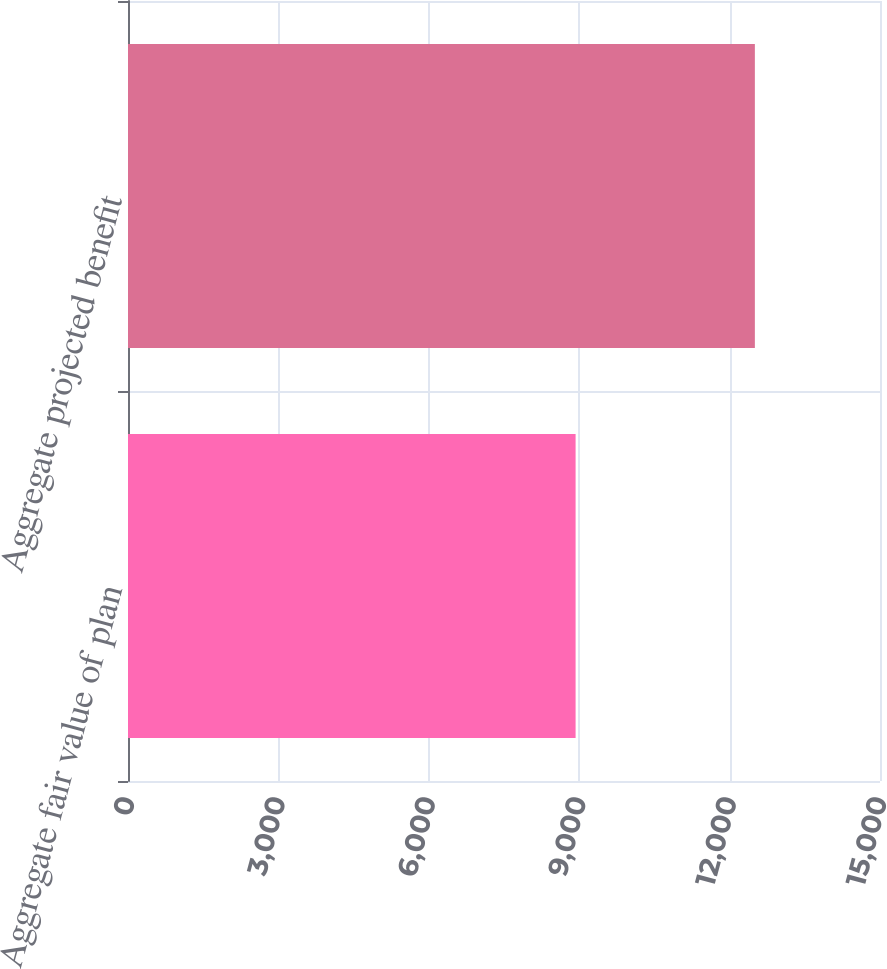Convert chart to OTSL. <chart><loc_0><loc_0><loc_500><loc_500><bar_chart><fcel>Aggregate fair value of plan<fcel>Aggregate projected benefit<nl><fcel>8928<fcel>12504<nl></chart> 